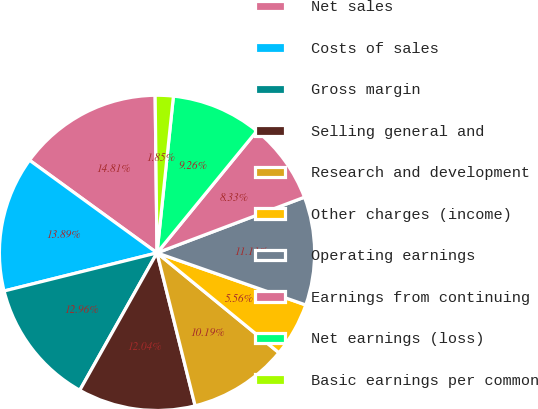Convert chart. <chart><loc_0><loc_0><loc_500><loc_500><pie_chart><fcel>Net sales<fcel>Costs of sales<fcel>Gross margin<fcel>Selling general and<fcel>Research and development<fcel>Other charges (income)<fcel>Operating earnings<fcel>Earnings from continuing<fcel>Net earnings (loss)<fcel>Basic earnings per common<nl><fcel>14.81%<fcel>13.89%<fcel>12.96%<fcel>12.04%<fcel>10.19%<fcel>5.56%<fcel>11.11%<fcel>8.33%<fcel>9.26%<fcel>1.85%<nl></chart> 